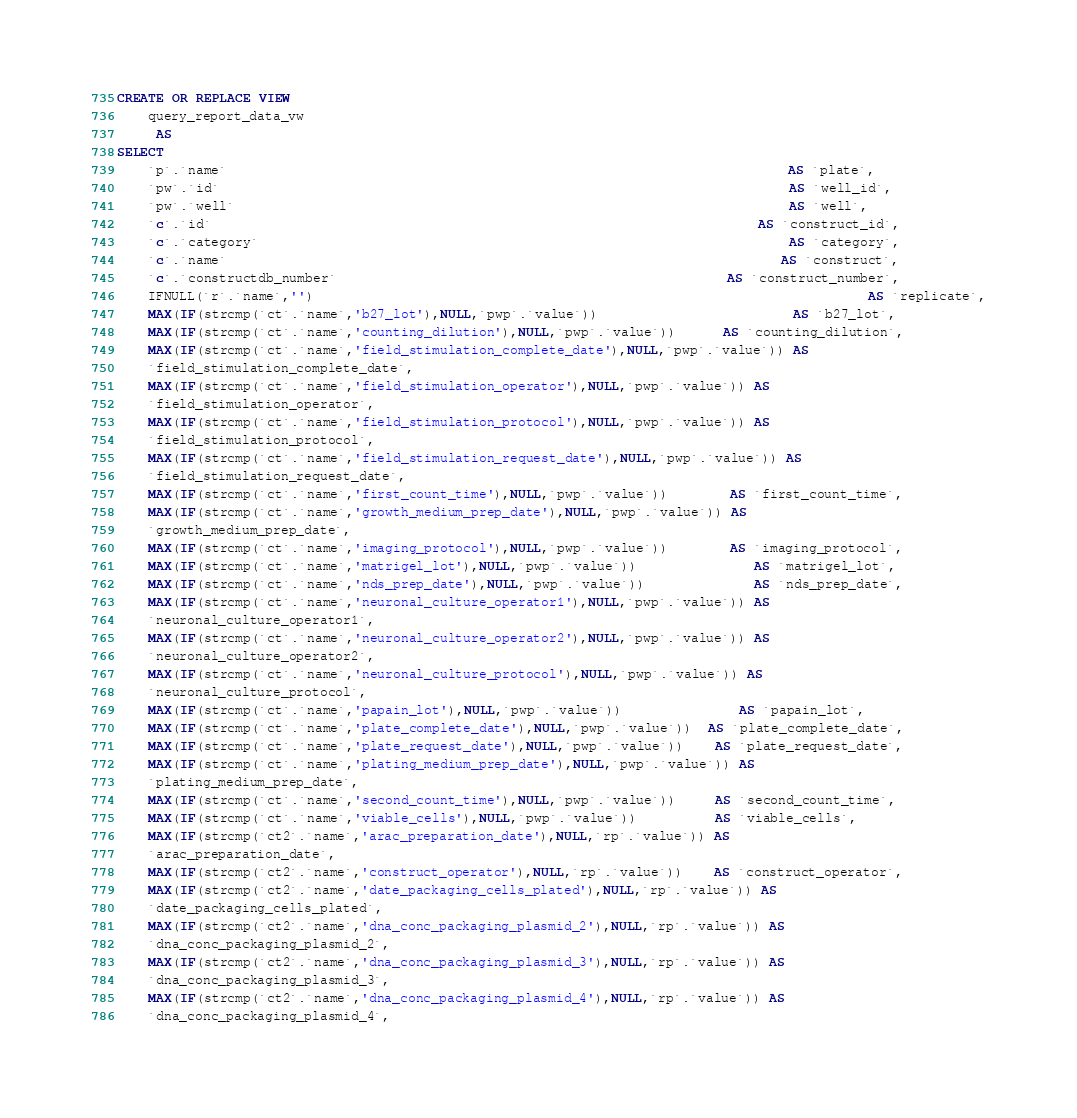<code> <loc_0><loc_0><loc_500><loc_500><_SQL_>CREATE OR REPLACE VIEW
    query_report_data_vw
     AS
SELECT
    `p`.`name`                                                                        AS `plate`,
    `pw`.`id`                                                                         AS `well_id`,
    `pw`.`well`                                                                       AS `well`,
    `c`.`id`                                                                      AS `construct_id`,
    `c`.`category`                                                                    AS `category`,
    `c`.`name`                                                                       AS `construct`,
    `c`.`constructdb_number`                                                  AS `construct_number`,
    IFNULL(`r`.`name`,'')                                                                       AS `replicate`,
    MAX(IF(strcmp(`ct`.`name`,'b27_lot'),NULL,`pwp`.`value`))                         AS `b27_lot`,
    MAX(IF(strcmp(`ct`.`name`,'counting_dilution'),NULL,`pwp`.`value`))      AS `counting_dilution`,
    MAX(IF(strcmp(`ct`.`name`,'field_stimulation_complete_date'),NULL,`pwp`.`value`)) AS
    `field_stimulation_complete_date`,
    MAX(IF(strcmp(`ct`.`name`,'field_stimulation_operator'),NULL,`pwp`.`value`)) AS
    `field_stimulation_operator`,
    MAX(IF(strcmp(`ct`.`name`,'field_stimulation_protocol'),NULL,`pwp`.`value`)) AS
    `field_stimulation_protocol`,
    MAX(IF(strcmp(`ct`.`name`,'field_stimulation_request_date'),NULL,`pwp`.`value`)) AS
    `field_stimulation_request_date`,
    MAX(IF(strcmp(`ct`.`name`,'first_count_time'),NULL,`pwp`.`value`))        AS `first_count_time`,
    MAX(IF(strcmp(`ct`.`name`,'growth_medium_prep_date'),NULL,`pwp`.`value`)) AS
    `growth_medium_prep_date`,
    MAX(IF(strcmp(`ct`.`name`,'imaging_protocol'),NULL,`pwp`.`value`))        AS `imaging_protocol`,
    MAX(IF(strcmp(`ct`.`name`,'matrigel_lot'),NULL,`pwp`.`value`))               AS `matrigel_lot`,
    MAX(IF(strcmp(`ct`.`name`,'nds_prep_date'),NULL,`pwp`.`value`))              AS `nds_prep_date`,
    MAX(IF(strcmp(`ct`.`name`,'neuronal_culture_operator1'),NULL,`pwp`.`value`)) AS
    `neuronal_culture_operator1`,
    MAX(IF(strcmp(`ct`.`name`,'neuronal_culture_operator2'),NULL,`pwp`.`value`)) AS
    `neuronal_culture_operator2`,
    MAX(IF(strcmp(`ct`.`name`,'neuronal_culture_protocol'),NULL,`pwp`.`value`)) AS
    `neuronal_culture_protocol`,
    MAX(IF(strcmp(`ct`.`name`,'papain_lot'),NULL,`pwp`.`value`))               AS `papain_lot`,
    MAX(IF(strcmp(`ct`.`name`,'plate_complete_date'),NULL,`pwp`.`value`))  AS `plate_complete_date`,
    MAX(IF(strcmp(`ct`.`name`,'plate_request_date'),NULL,`pwp`.`value`))    AS `plate_request_date`,
    MAX(IF(strcmp(`ct`.`name`,'plating_medium_prep_date'),NULL,`pwp`.`value`)) AS
    `plating_medium_prep_date`,
    MAX(IF(strcmp(`ct`.`name`,'second_count_time'),NULL,`pwp`.`value`))     AS `second_count_time`,
    MAX(IF(strcmp(`ct`.`name`,'viable_cells'),NULL,`pwp`.`value`))          AS `viable_cells`,
    MAX(IF(strcmp(`ct2`.`name`,'arac_preparation_date'),NULL,`rp`.`value`)) AS
    `arac_preparation_date`,
    MAX(IF(strcmp(`ct2`.`name`,'construct_operator'),NULL,`rp`.`value`))    AS `construct_operator`,
    MAX(IF(strcmp(`ct2`.`name`,'date_packaging_cells_plated'),NULL,`rp`.`value`)) AS
    `date_packaging_cells_plated`,
    MAX(IF(strcmp(`ct2`.`name`,'dna_conc_packaging_plasmid_2'),NULL,`rp`.`value`)) AS
    `dna_conc_packaging_plasmid_2`,
    MAX(IF(strcmp(`ct2`.`name`,'dna_conc_packaging_plasmid_3'),NULL,`rp`.`value`)) AS
    `dna_conc_packaging_plasmid_3`,
    MAX(IF(strcmp(`ct2`.`name`,'dna_conc_packaging_plasmid_4'),NULL,`rp`.`value`)) AS
    `dna_conc_packaging_plasmid_4`,</code> 